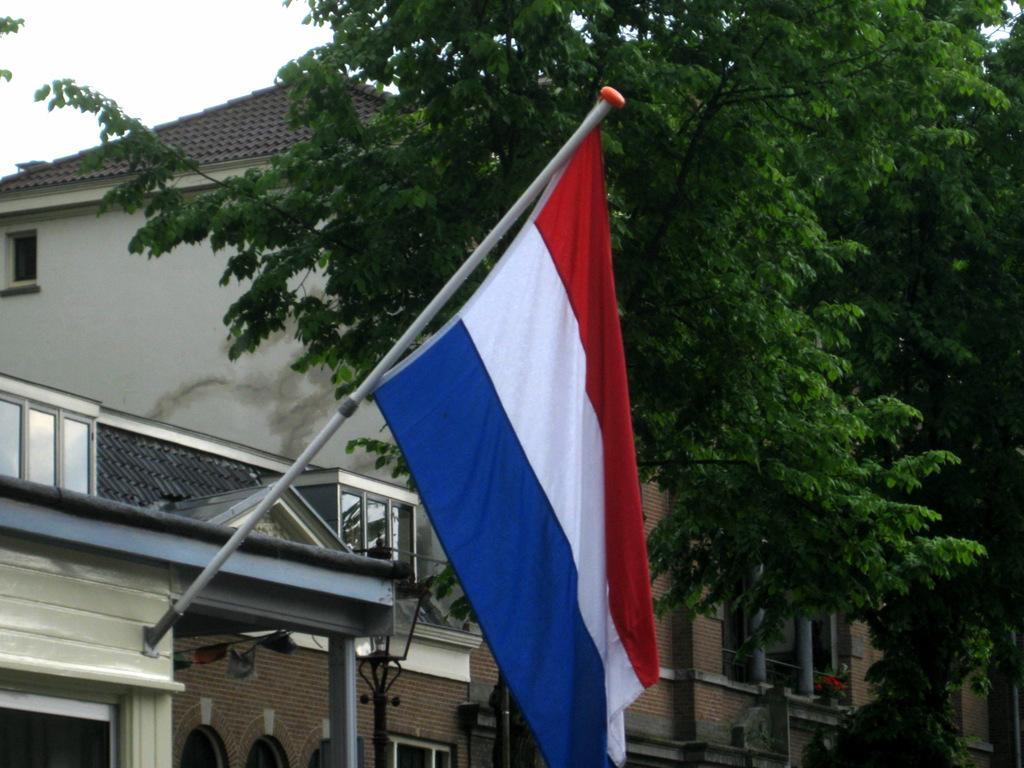What is the main object in the image? There is a flag in the image. Where is the flag located? The flag is hung on top of a house. What can be seen behind the flag? There are trees and buildings visible behind the flag. How many eggs are being controlled by the flag in the image? There are no eggs or control mechanisms present in the image; it features a flag hung on top of a house with trees and buildings visible in the background. 